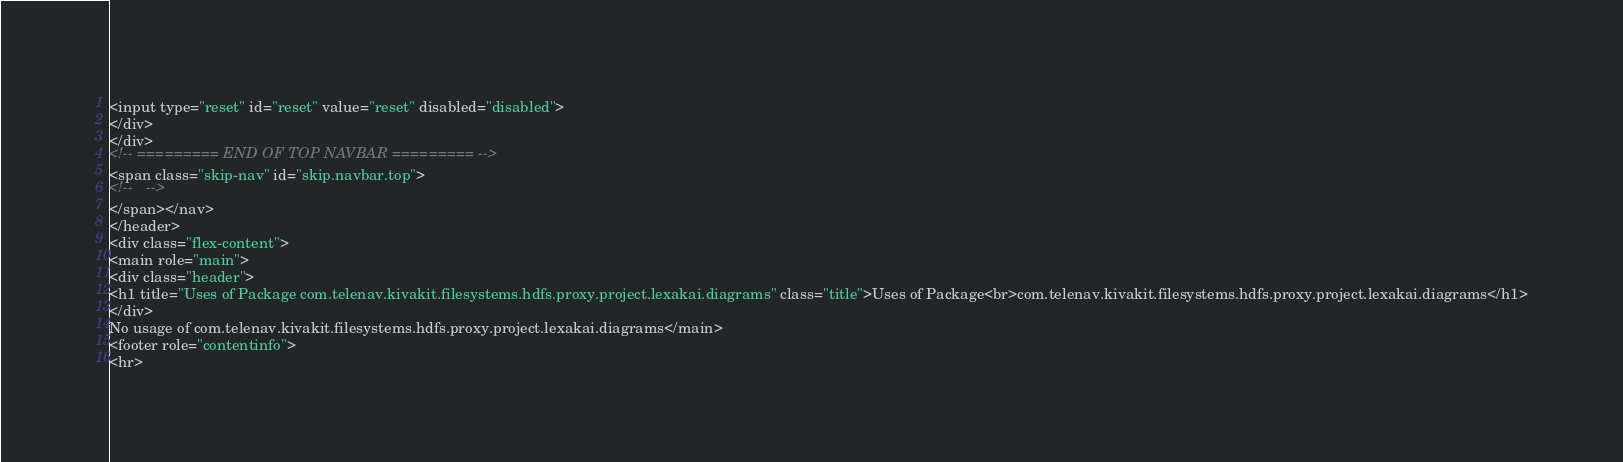<code> <loc_0><loc_0><loc_500><loc_500><_HTML_><input type="reset" id="reset" value="reset" disabled="disabled">
</div>
</div>
<!-- ========= END OF TOP NAVBAR ========= -->
<span class="skip-nav" id="skip.navbar.top">
<!--   -->
</span></nav>
</header>
<div class="flex-content">
<main role="main">
<div class="header">
<h1 title="Uses of Package com.telenav.kivakit.filesystems.hdfs.proxy.project.lexakai.diagrams" class="title">Uses of Package<br>com.telenav.kivakit.filesystems.hdfs.proxy.project.lexakai.diagrams</h1>
</div>
No usage of com.telenav.kivakit.filesystems.hdfs.proxy.project.lexakai.diagrams</main>
<footer role="contentinfo">
<hr></code> 